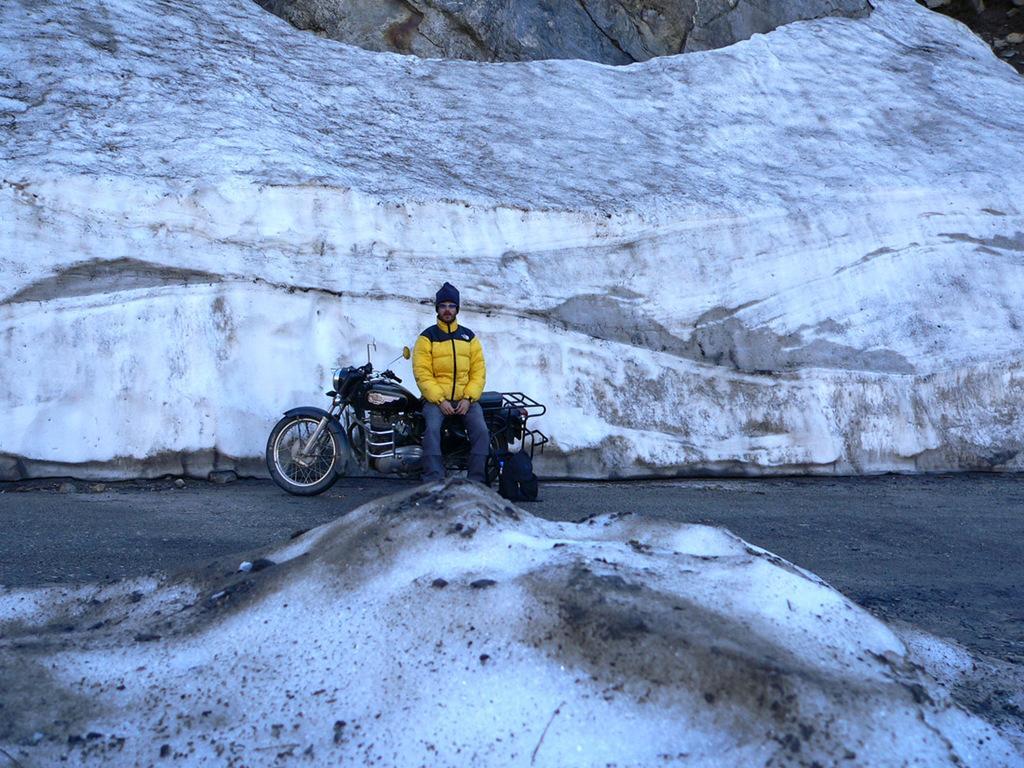In one or two sentences, can you explain what this image depicts? Here we can see snow. In the background there is a man sitting on a bike on the road and there is a bag at his legs and we can also see a big ice rock and an object. 